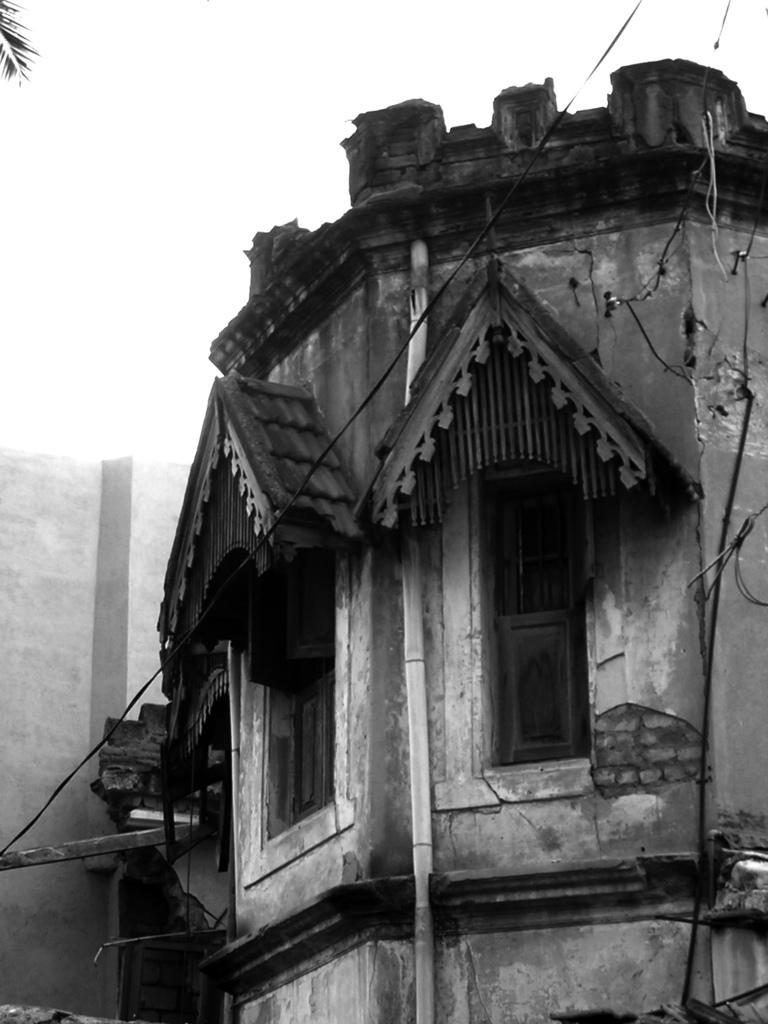Can you describe this image briefly? This is an edited picture. In the foreground of the picture there are cables and we can see stem of a tree. In the center of the picture there is a building looking like a old construction. At the top it is not clear. On the left it is well. 